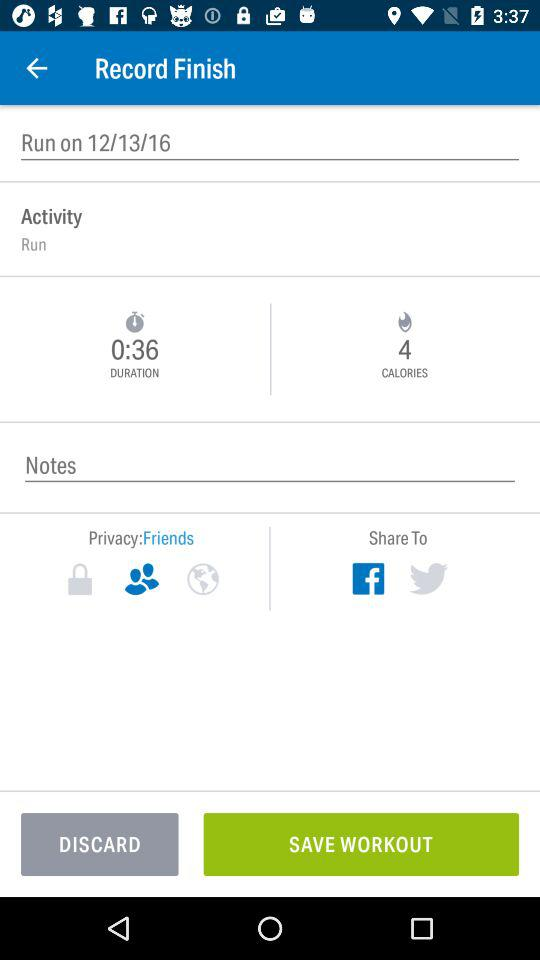What is the activity name? The activity name is "Run". 